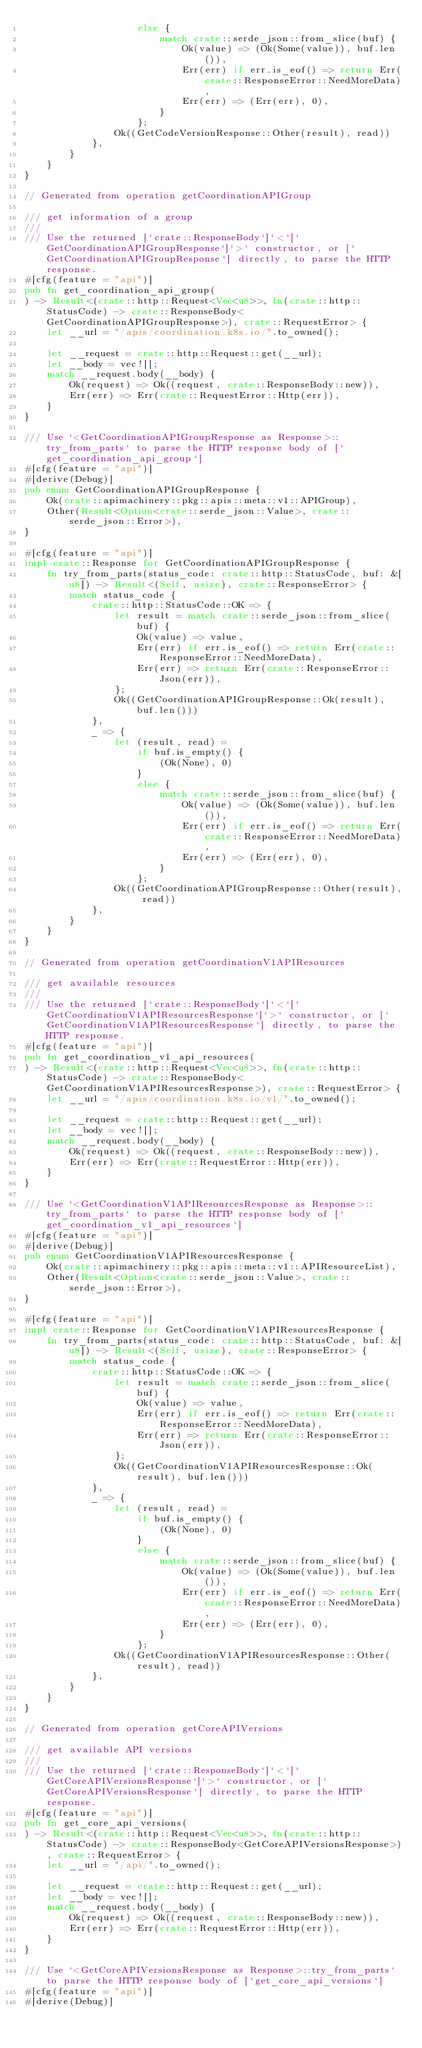Convert code to text. <code><loc_0><loc_0><loc_500><loc_500><_Rust_>                    else {
                        match crate::serde_json::from_slice(buf) {
                            Ok(value) => (Ok(Some(value)), buf.len()),
                            Err(err) if err.is_eof() => return Err(crate::ResponseError::NeedMoreData),
                            Err(err) => (Err(err), 0),
                        }
                    };
                Ok((GetCodeVersionResponse::Other(result), read))
            },
        }
    }
}

// Generated from operation getCoordinationAPIGroup

/// get information of a group
///
/// Use the returned [`crate::ResponseBody`]`<`[`GetCoordinationAPIGroupResponse`]`>` constructor, or [`GetCoordinationAPIGroupResponse`] directly, to parse the HTTP response.
#[cfg(feature = "api")]
pub fn get_coordination_api_group(
) -> Result<(crate::http::Request<Vec<u8>>, fn(crate::http::StatusCode) -> crate::ResponseBody<GetCoordinationAPIGroupResponse>), crate::RequestError> {
    let __url = "/apis/coordination.k8s.io/".to_owned();

    let __request = crate::http::Request::get(__url);
    let __body = vec![];
    match __request.body(__body) {
        Ok(request) => Ok((request, crate::ResponseBody::new)),
        Err(err) => Err(crate::RequestError::Http(err)),
    }
}

/// Use `<GetCoordinationAPIGroupResponse as Response>::try_from_parts` to parse the HTTP response body of [`get_coordination_api_group`]
#[cfg(feature = "api")]
#[derive(Debug)]
pub enum GetCoordinationAPIGroupResponse {
    Ok(crate::apimachinery::pkg::apis::meta::v1::APIGroup),
    Other(Result<Option<crate::serde_json::Value>, crate::serde_json::Error>),
}

#[cfg(feature = "api")]
impl crate::Response for GetCoordinationAPIGroupResponse {
    fn try_from_parts(status_code: crate::http::StatusCode, buf: &[u8]) -> Result<(Self, usize), crate::ResponseError> {
        match status_code {
            crate::http::StatusCode::OK => {
                let result = match crate::serde_json::from_slice(buf) {
                    Ok(value) => value,
                    Err(err) if err.is_eof() => return Err(crate::ResponseError::NeedMoreData),
                    Err(err) => return Err(crate::ResponseError::Json(err)),
                };
                Ok((GetCoordinationAPIGroupResponse::Ok(result), buf.len()))
            },
            _ => {
                let (result, read) =
                    if buf.is_empty() {
                        (Ok(None), 0)
                    }
                    else {
                        match crate::serde_json::from_slice(buf) {
                            Ok(value) => (Ok(Some(value)), buf.len()),
                            Err(err) if err.is_eof() => return Err(crate::ResponseError::NeedMoreData),
                            Err(err) => (Err(err), 0),
                        }
                    };
                Ok((GetCoordinationAPIGroupResponse::Other(result), read))
            },
        }
    }
}

// Generated from operation getCoordinationV1APIResources

/// get available resources
///
/// Use the returned [`crate::ResponseBody`]`<`[`GetCoordinationV1APIResourcesResponse`]`>` constructor, or [`GetCoordinationV1APIResourcesResponse`] directly, to parse the HTTP response.
#[cfg(feature = "api")]
pub fn get_coordination_v1_api_resources(
) -> Result<(crate::http::Request<Vec<u8>>, fn(crate::http::StatusCode) -> crate::ResponseBody<GetCoordinationV1APIResourcesResponse>), crate::RequestError> {
    let __url = "/apis/coordination.k8s.io/v1/".to_owned();

    let __request = crate::http::Request::get(__url);
    let __body = vec![];
    match __request.body(__body) {
        Ok(request) => Ok((request, crate::ResponseBody::new)),
        Err(err) => Err(crate::RequestError::Http(err)),
    }
}

/// Use `<GetCoordinationV1APIResourcesResponse as Response>::try_from_parts` to parse the HTTP response body of [`get_coordination_v1_api_resources`]
#[cfg(feature = "api")]
#[derive(Debug)]
pub enum GetCoordinationV1APIResourcesResponse {
    Ok(crate::apimachinery::pkg::apis::meta::v1::APIResourceList),
    Other(Result<Option<crate::serde_json::Value>, crate::serde_json::Error>),
}

#[cfg(feature = "api")]
impl crate::Response for GetCoordinationV1APIResourcesResponse {
    fn try_from_parts(status_code: crate::http::StatusCode, buf: &[u8]) -> Result<(Self, usize), crate::ResponseError> {
        match status_code {
            crate::http::StatusCode::OK => {
                let result = match crate::serde_json::from_slice(buf) {
                    Ok(value) => value,
                    Err(err) if err.is_eof() => return Err(crate::ResponseError::NeedMoreData),
                    Err(err) => return Err(crate::ResponseError::Json(err)),
                };
                Ok((GetCoordinationV1APIResourcesResponse::Ok(result), buf.len()))
            },
            _ => {
                let (result, read) =
                    if buf.is_empty() {
                        (Ok(None), 0)
                    }
                    else {
                        match crate::serde_json::from_slice(buf) {
                            Ok(value) => (Ok(Some(value)), buf.len()),
                            Err(err) if err.is_eof() => return Err(crate::ResponseError::NeedMoreData),
                            Err(err) => (Err(err), 0),
                        }
                    };
                Ok((GetCoordinationV1APIResourcesResponse::Other(result), read))
            },
        }
    }
}

// Generated from operation getCoreAPIVersions

/// get available API versions
///
/// Use the returned [`crate::ResponseBody`]`<`[`GetCoreAPIVersionsResponse`]`>` constructor, or [`GetCoreAPIVersionsResponse`] directly, to parse the HTTP response.
#[cfg(feature = "api")]
pub fn get_core_api_versions(
) -> Result<(crate::http::Request<Vec<u8>>, fn(crate::http::StatusCode) -> crate::ResponseBody<GetCoreAPIVersionsResponse>), crate::RequestError> {
    let __url = "/api/".to_owned();

    let __request = crate::http::Request::get(__url);
    let __body = vec![];
    match __request.body(__body) {
        Ok(request) => Ok((request, crate::ResponseBody::new)),
        Err(err) => Err(crate::RequestError::Http(err)),
    }
}

/// Use `<GetCoreAPIVersionsResponse as Response>::try_from_parts` to parse the HTTP response body of [`get_core_api_versions`]
#[cfg(feature = "api")]
#[derive(Debug)]</code> 